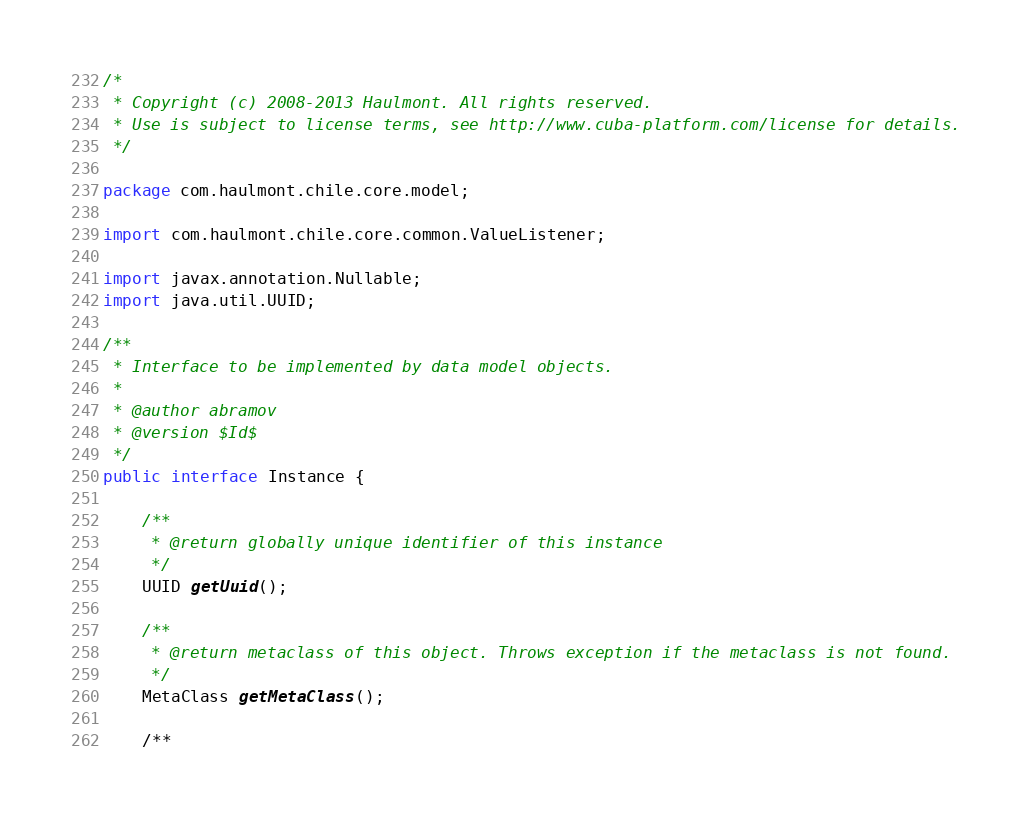Convert code to text. <code><loc_0><loc_0><loc_500><loc_500><_Java_>/*
 * Copyright (c) 2008-2013 Haulmont. All rights reserved.
 * Use is subject to license terms, see http://www.cuba-platform.com/license for details.
 */

package com.haulmont.chile.core.model;

import com.haulmont.chile.core.common.ValueListener;

import javax.annotation.Nullable;
import java.util.UUID;

/**
 * Interface to be implemented by data model objects.
 *
 * @author abramov
 * @version $Id$
 */
public interface Instance {

    /**
     * @return globally unique identifier of this instance
     */
    UUID getUuid();

    /**
     * @return metaclass of this object. Throws exception if the metaclass is not found.
     */
    MetaClass getMetaClass();
    
    /**</code> 